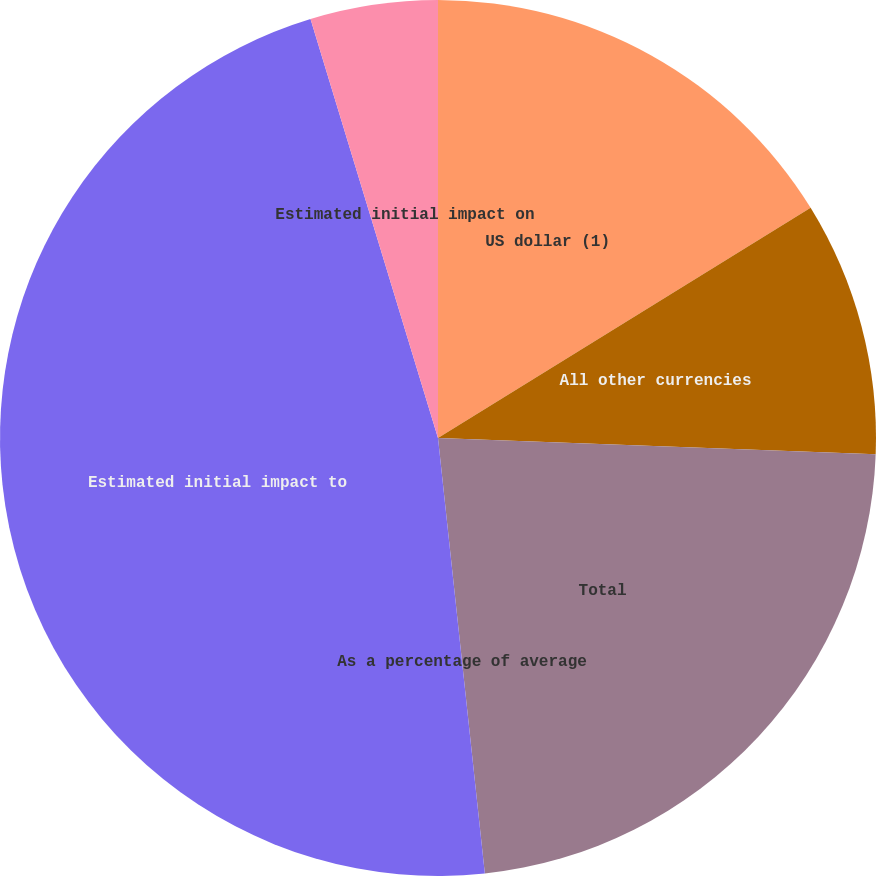Convert chart to OTSL. <chart><loc_0><loc_0><loc_500><loc_500><pie_chart><fcel>US dollar (1)<fcel>All other currencies<fcel>Total<fcel>As a percentage of average<fcel>Estimated initial impact to<fcel>Estimated initial impact on<nl><fcel>16.19%<fcel>9.4%<fcel>22.7%<fcel>0.0%<fcel>47.0%<fcel>4.7%<nl></chart> 